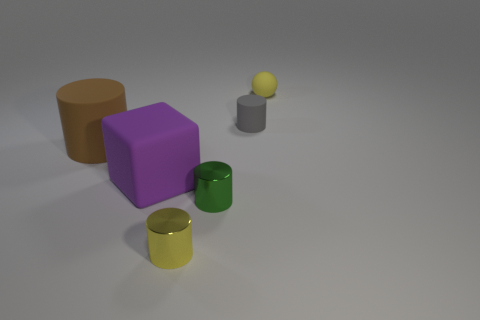What number of balls are yellow things or large purple objects?
Your answer should be compact. 1. Are the tiny yellow object on the left side of the small yellow rubber sphere and the green thing made of the same material?
Offer a very short reply. Yes. What number of other things are there of the same size as the gray thing?
Offer a terse response. 3. What number of tiny objects are either brown cylinders or purple things?
Offer a terse response. 0. Are there more large matte objects that are left of the big purple thing than purple blocks to the right of the tiny yellow cylinder?
Make the answer very short. Yes. Does the metal thing that is to the left of the tiny green metal thing have the same color as the matte ball?
Offer a very short reply. Yes. Are there any other things of the same color as the ball?
Your response must be concise. Yes. Are there more tiny yellow things in front of the big brown matte cylinder than green metallic balls?
Offer a terse response. Yes. Do the purple cube and the brown matte cylinder have the same size?
Ensure brevity in your answer.  Yes. What material is the yellow thing that is the same shape as the green metal object?
Make the answer very short. Metal. 